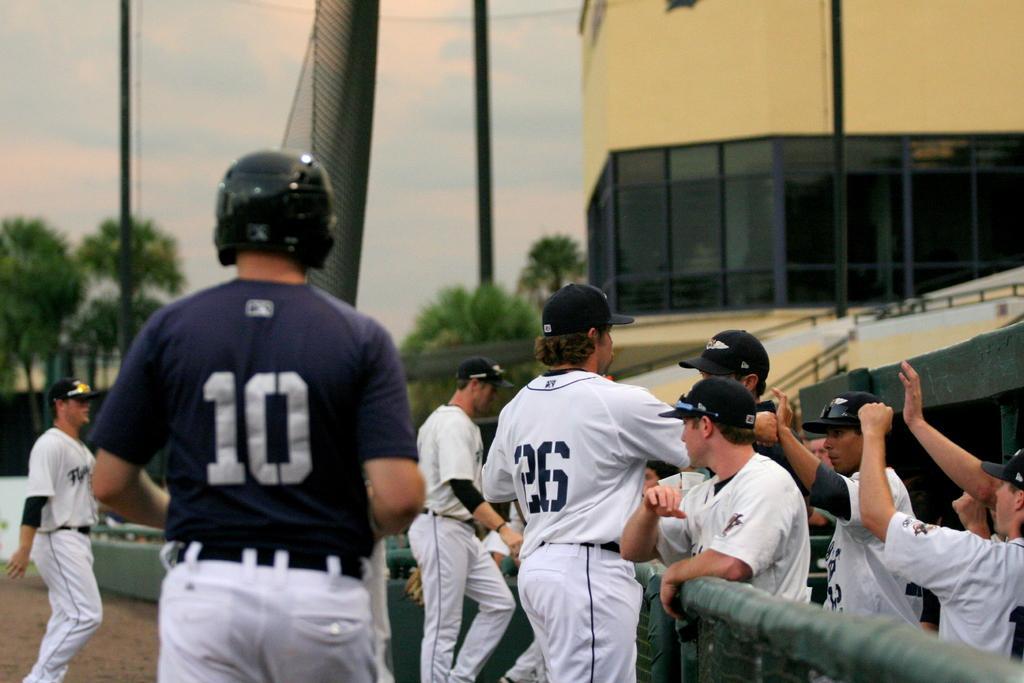In one or two sentences, can you explain what this image depicts? In this picture there are sportsmen in the center of the image and there is a boundary at the bottom side of the image and there is a building at the top side of the image and there are trees, poles, and a net in the background area of the image. 